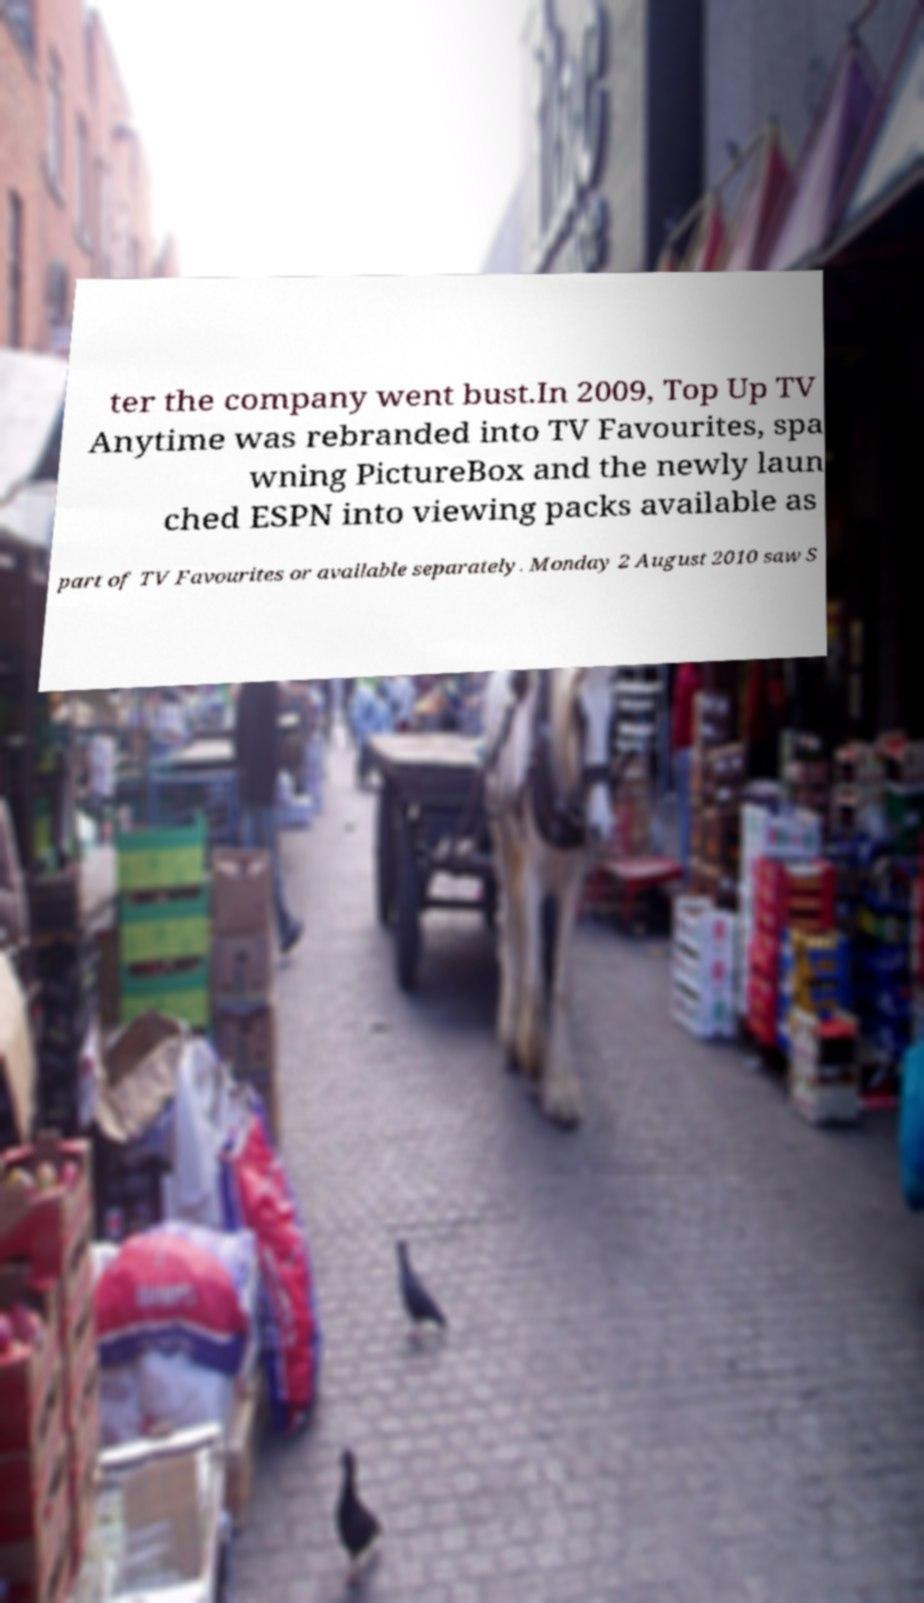What messages or text are displayed in this image? I need them in a readable, typed format. ter the company went bust.In 2009, Top Up TV Anytime was rebranded into TV Favourites, spa wning PictureBox and the newly laun ched ESPN into viewing packs available as part of TV Favourites or available separately. Monday 2 August 2010 saw S 